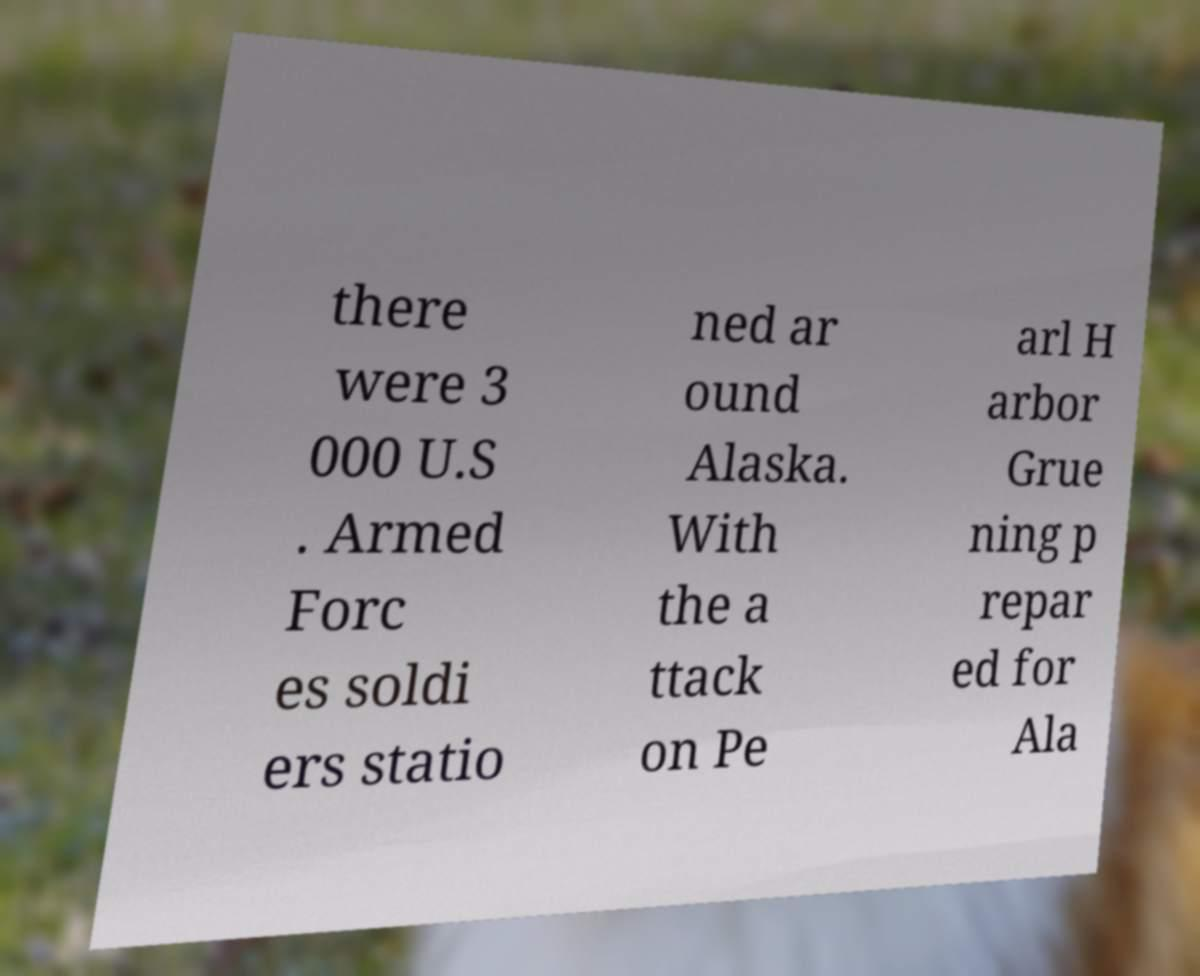What messages or text are displayed in this image? I need them in a readable, typed format. there were 3 000 U.S . Armed Forc es soldi ers statio ned ar ound Alaska. With the a ttack on Pe arl H arbor Grue ning p repar ed for Ala 